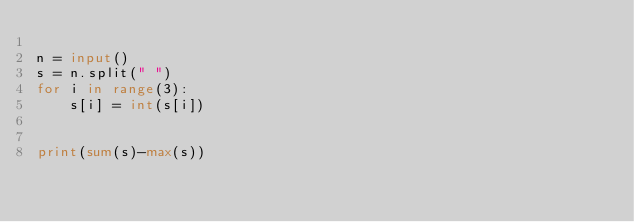<code> <loc_0><loc_0><loc_500><loc_500><_Python_>
n = input()
s = n.split(" ")
for i in range(3):
    s[i] = int(s[i])


print(sum(s)-max(s))</code> 